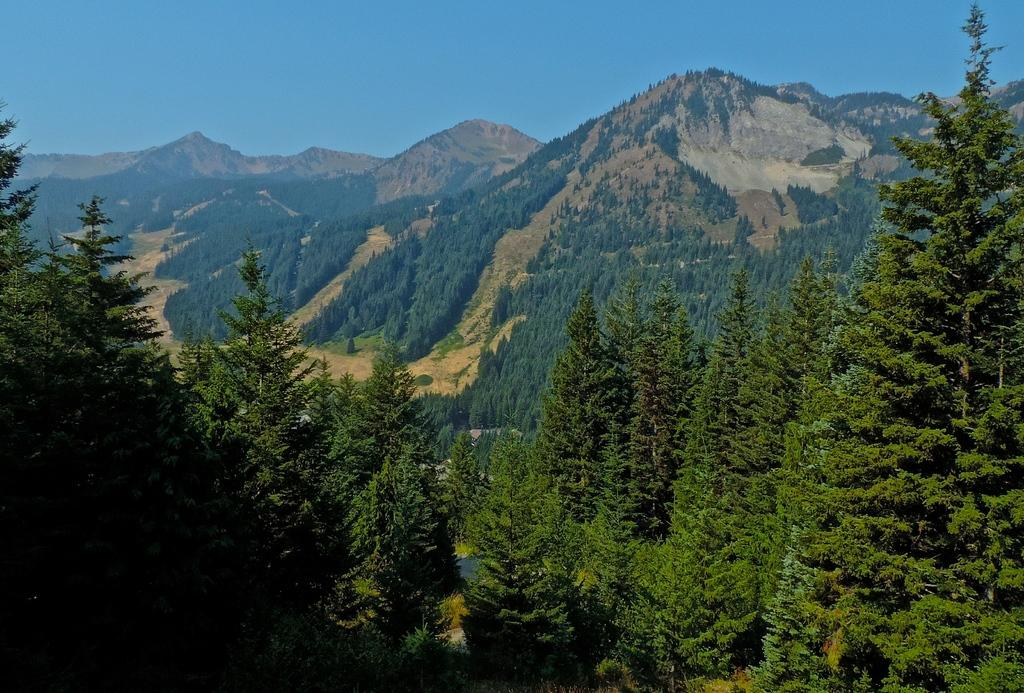What type of vegetation is at the bottom of the image? There are trees at the bottom of the image. What is located behind the trees in the image? There are hills behind the trees. What is visible at the top of the image? The sky is visible at the top of the image. Are there any icicles hanging from the trees in the image? There are no icicles present in the image; it appears to be a scene with trees, hills, and sky. Can you describe the scene where the characters are flying in the image? There are no characters or flying depicted in the image; it features trees, hills, and sky. 